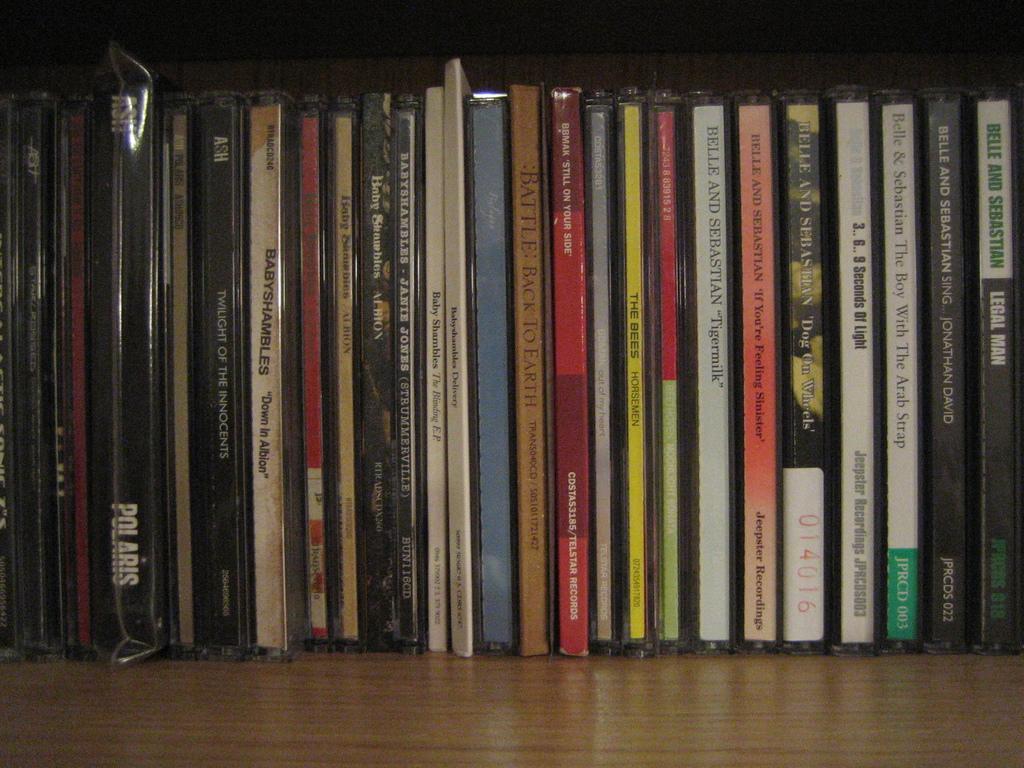What is the last cd on the right?
Keep it short and to the point. Legal man. What artists made the boy with the arab strap?
Keep it short and to the point. Belle & sebastian. 